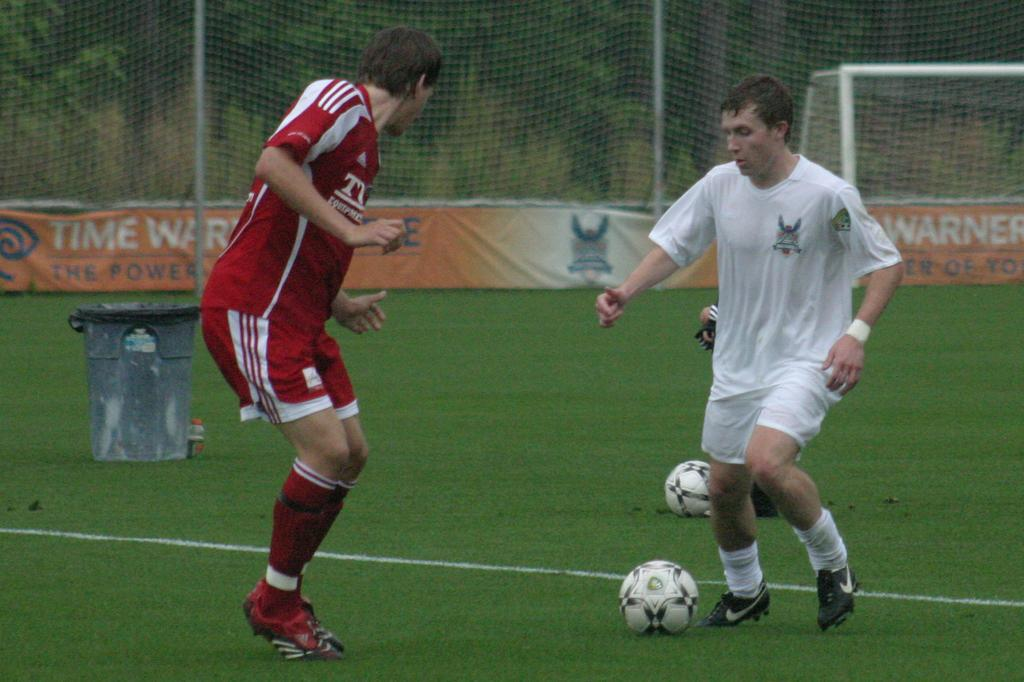Provide a one-sentence caption for the provided image. Two men face each other on a soccer field lined with Time Warner banners. 